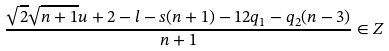Convert formula to latex. <formula><loc_0><loc_0><loc_500><loc_500>\frac { \sqrt { 2 } \sqrt { n + 1 } u + 2 - l - s ( n + 1 ) - 1 2 q _ { 1 } - q _ { 2 } ( n - 3 ) } { n + 1 } \in { Z }</formula> 